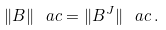Convert formula to latex. <formula><loc_0><loc_0><loc_500><loc_500>\| B \| _ { \ } a c = \| B ^ { J } \| _ { \ } a c \, .</formula> 